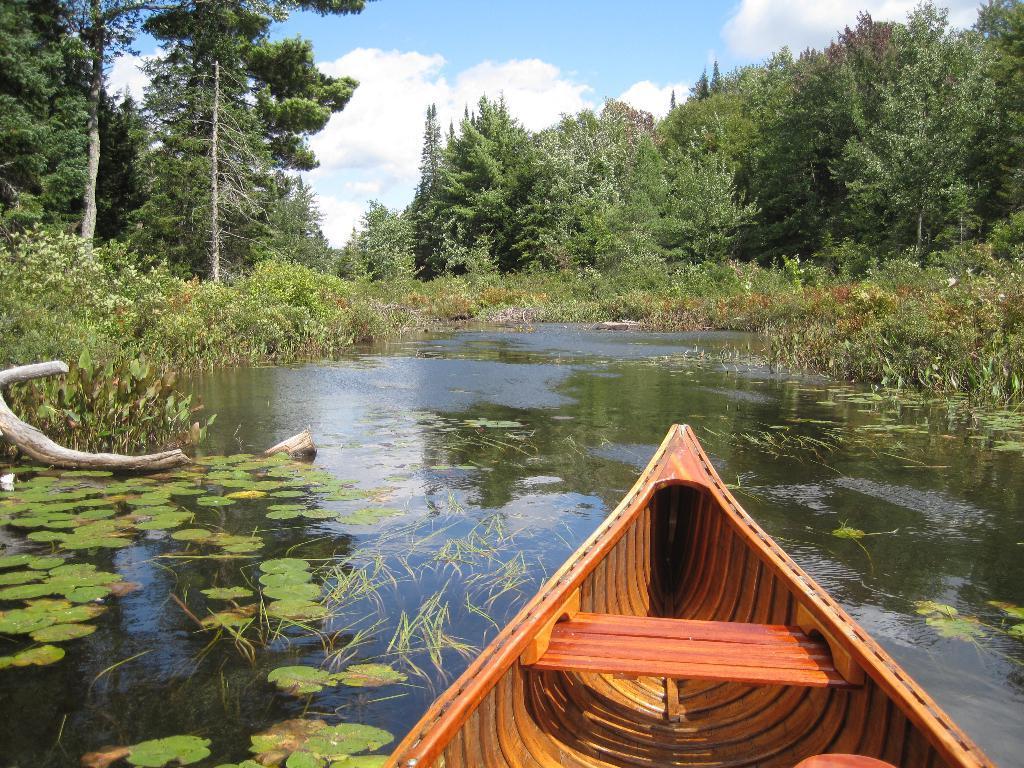Could you give a brief overview of what you see in this image? In this picture we can see a boat, leaves, wooden sticks on the water and in the background we can see trees and the sky with clouds. 